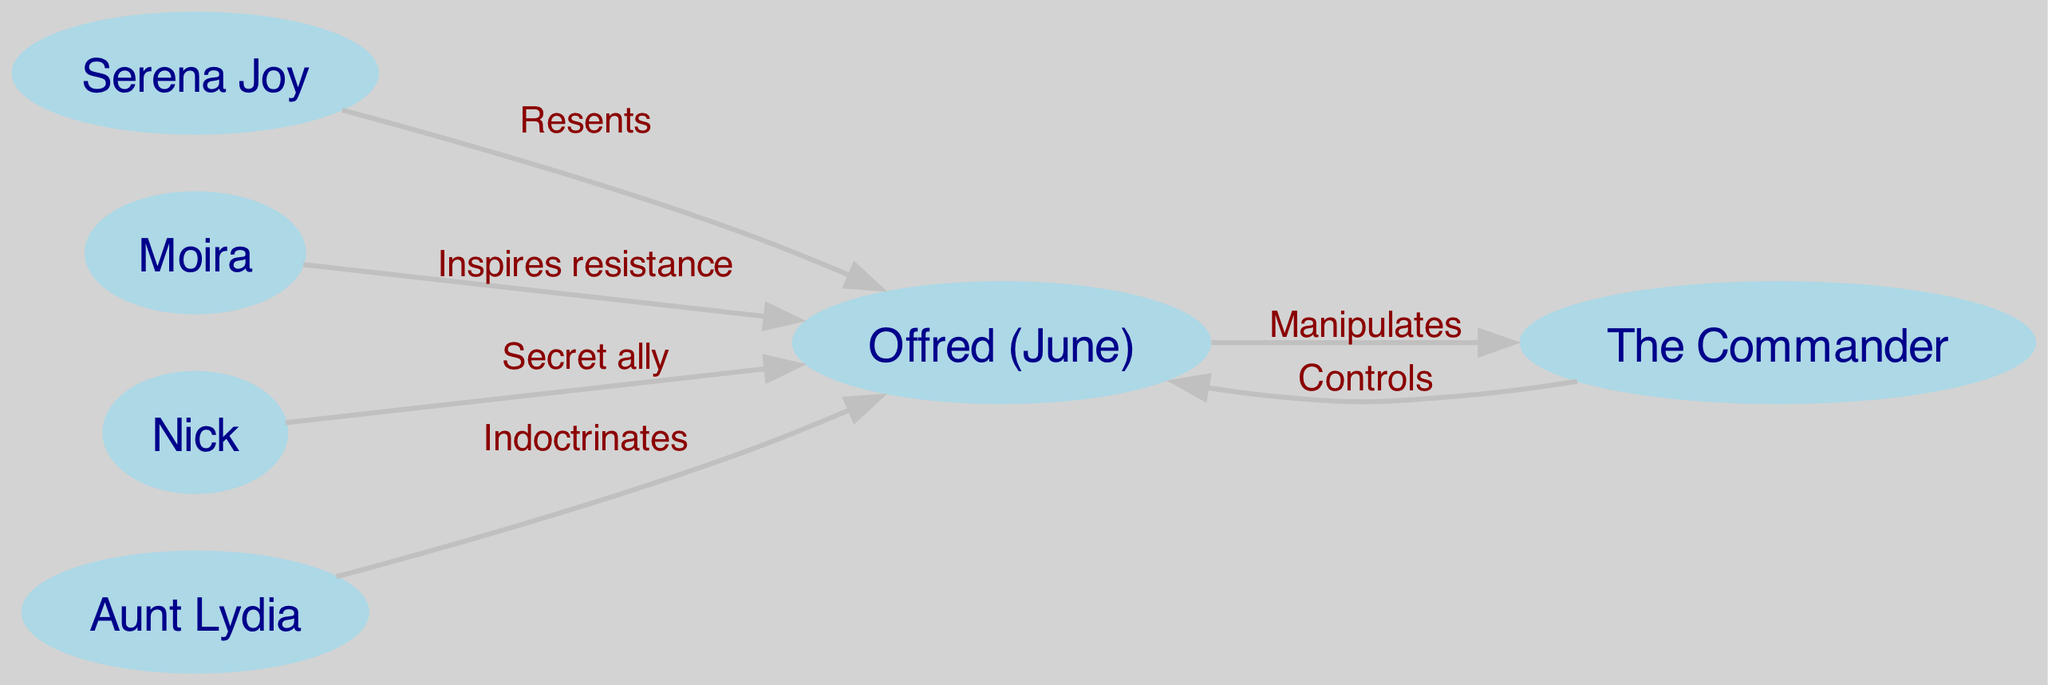What is the total number of characters represented in the diagram? The diagram includes six distinct characters: Offred, The Commander, Serena Joy, Moira, Nick, and Aunt Lydia. Counting these individual nodes gives a total of 6 characters represented.
Answer: 6 Which character has a relationship labeled "Controls" with Offred? The edge labeled "Controls" leads from The Commander to Offred, indicating that The Commander has a controlling relationship over Offred.
Answer: The Commander How many edges are there in total connecting the characters? The diagram contains five edges that describe various relationships between the characters. By counting each edge listed in the data, we find a total of 5 edges.
Answer: 5 What is the nature of the relationship between Moira and Offred? The edge linking Moira to Offred is labeled "Inspires resistance," denoting that Moira plays a crucial role in motivating Offred to resist the oppressive system.
Answer: Inspires resistance Who does Offred manipulate according to the diagram? The edge that indicates manipulation goes from Offred to The Commander, suggesting that Offred engages in manipulative behavior towards The Commander to navigate her situation.
Answer: The Commander Which character is labeled as a "Secret ally" of Offred? The diagram shows an edge leading from Nick to Offred, marked as "Secret ally," which identifies Nick's supportive and clandestine role in Offred's life.
Answer: Nick Which character is responsible for indoctrinating Offred? The edge from Aunt Lydia to Offred is labeled "Indoctrinates," indicating that Aunt Lydia holds a significant role in indoctrinating Offred with the regime's beliefs and values.
Answer: Aunt Lydia Which character does Serena Joy resent in the diagram? The edge connecting Serena Joy to Offred is labeled "Resents," demonstrating that Serena Joy harbors feelings of resentment towards Offred.
Answer: Offred Which character is influenced by more than one relationship? Offred is the connecting node influenced by multiple relationships: she is controlled by The Commander, resented by Serena Joy, inspired by Moira, and manipulated by The Commander. This showcases Offred’s central role in the character relationships.
Answer: Offred 